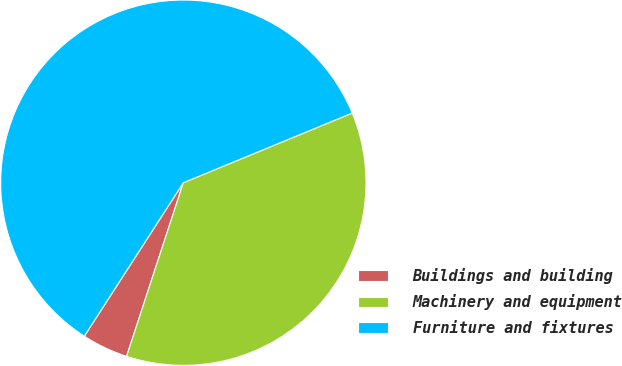Convert chart to OTSL. <chart><loc_0><loc_0><loc_500><loc_500><pie_chart><fcel>Buildings and building<fcel>Machinery and equipment<fcel>Furniture and fixtures<nl><fcel>4.09%<fcel>36.26%<fcel>59.65%<nl></chart> 